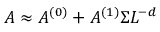Convert formula to latex. <formula><loc_0><loc_0><loc_500><loc_500>A \approx A ^ { ( 0 ) } + A ^ { ( 1 ) } \Sigma L ^ { - d }</formula> 